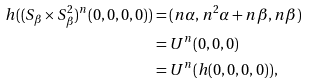<formula> <loc_0><loc_0><loc_500><loc_500>h ( ( S _ { \beta } \times S _ { \beta } ^ { 2 } ) ^ { n } ( 0 , 0 , 0 , 0 ) ) & = ( n \alpha , n ^ { 2 } \alpha + n \beta , n \beta ) \\ & = U ^ { n } ( 0 , 0 , 0 ) \\ & = U ^ { n } ( h ( 0 , 0 , 0 , 0 ) ) ,</formula> 